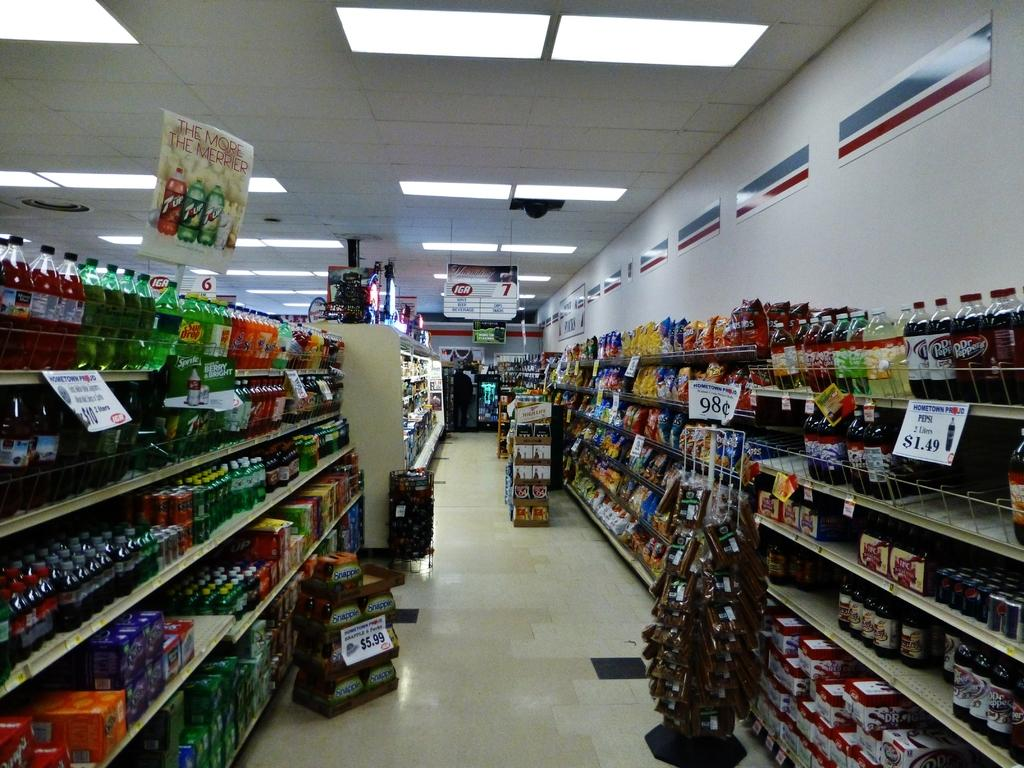<image>
Relay a brief, clear account of the picture shown. A store features Pepsi 2 liter bottles being sold for $1.49. 